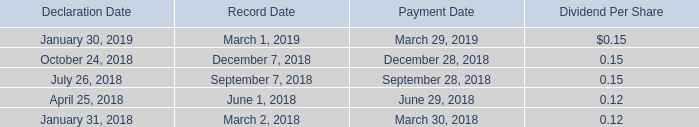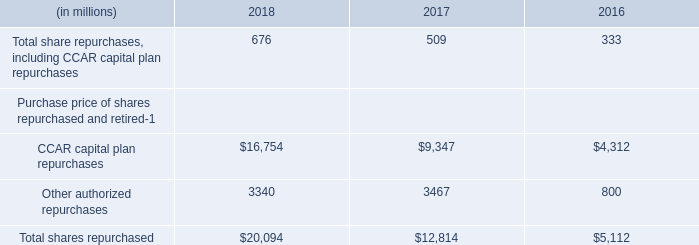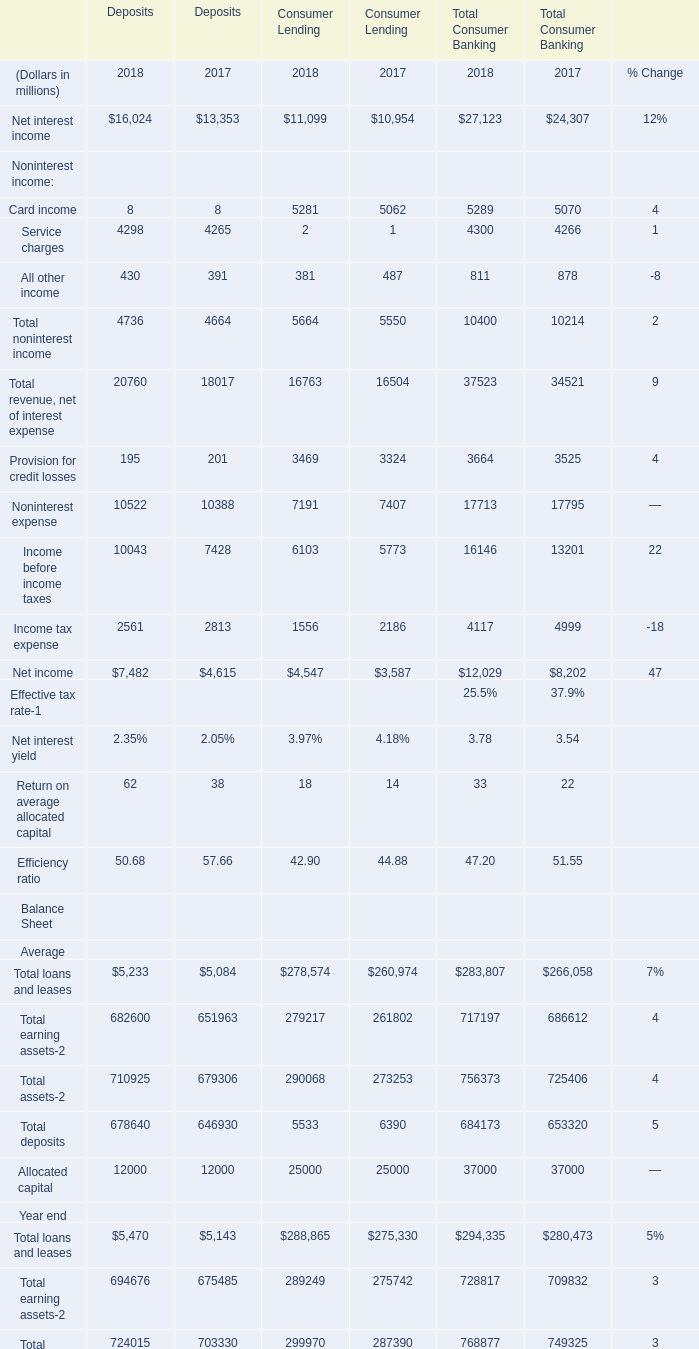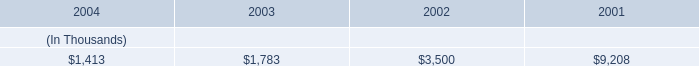what are the receivables from the money pool as a percentage of additional common stock dividends paid in 2003? 
Computations: ((1783 / 1000) / 2.2)
Answer: 0.81045. 